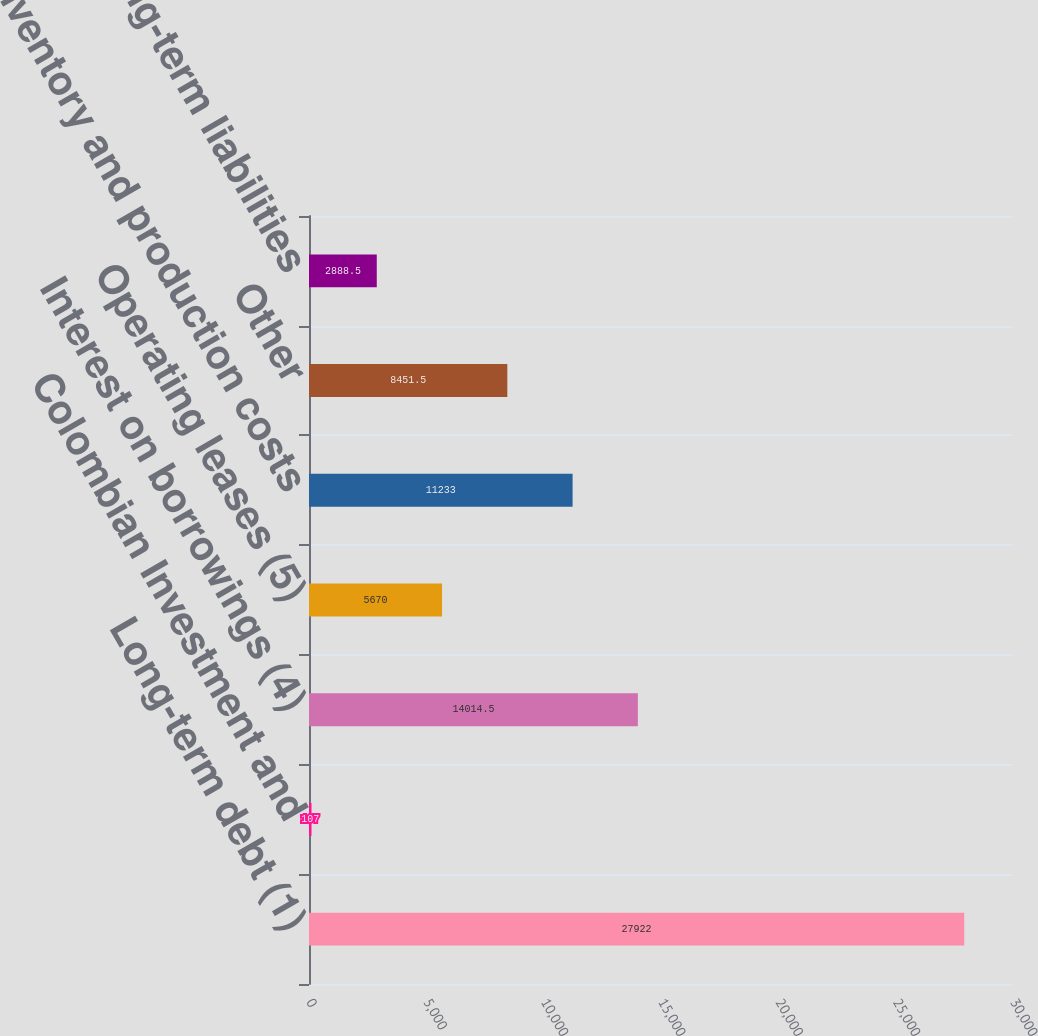Convert chart. <chart><loc_0><loc_0><loc_500><loc_500><bar_chart><fcel>Long-term debt (1)<fcel>Colombian Investment and<fcel>Interest on borrowings (4)<fcel>Operating leases (5)<fcel>Inventory and production costs<fcel>Other<fcel>Other long-term liabilities<nl><fcel>27922<fcel>107<fcel>14014.5<fcel>5670<fcel>11233<fcel>8451.5<fcel>2888.5<nl></chart> 